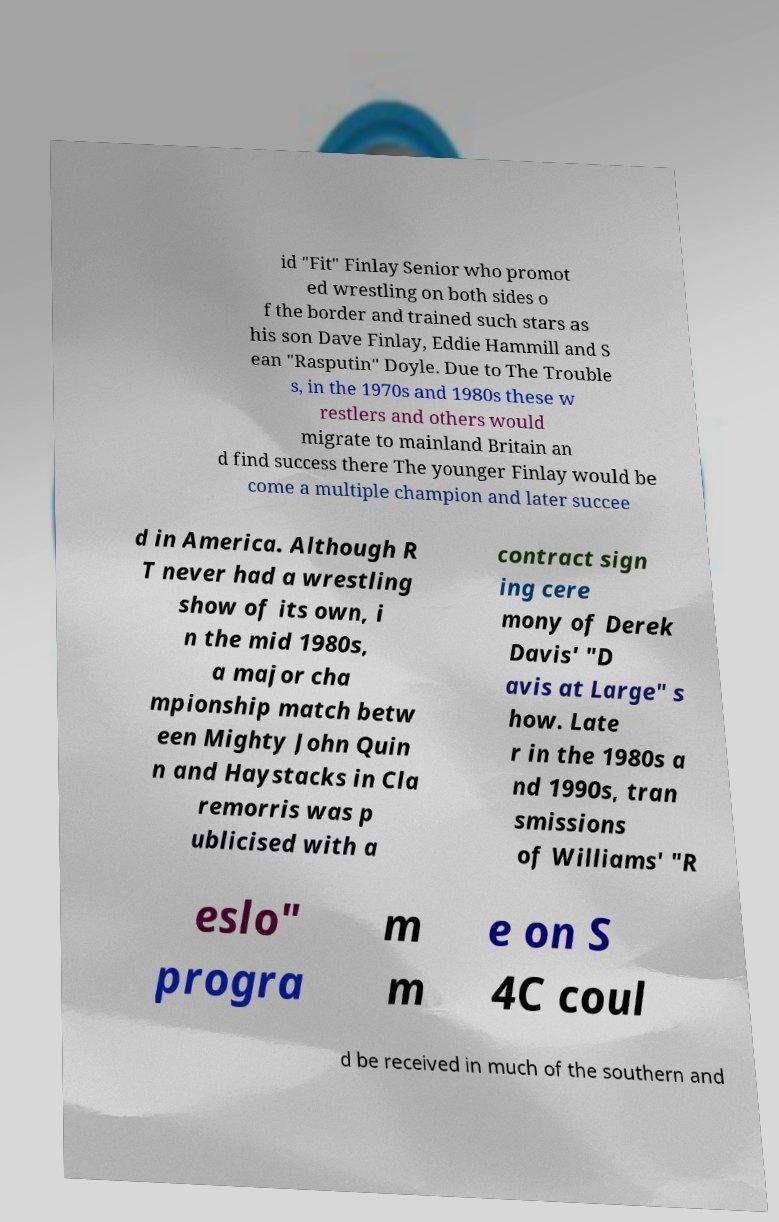Can you accurately transcribe the text from the provided image for me? id "Fit" Finlay Senior who promot ed wrestling on both sides o f the border and trained such stars as his son Dave Finlay, Eddie Hammill and S ean "Rasputin" Doyle. Due to The Trouble s, in the 1970s and 1980s these w restlers and others would migrate to mainland Britain an d find success there The younger Finlay would be come a multiple champion and later succee d in America. Although R T never had a wrestling show of its own, i n the mid 1980s, a major cha mpionship match betw een Mighty John Quin n and Haystacks in Cla remorris was p ublicised with a contract sign ing cere mony of Derek Davis' "D avis at Large" s how. Late r in the 1980s a nd 1990s, tran smissions of Williams' "R eslo" progra m m e on S 4C coul d be received in much of the southern and 